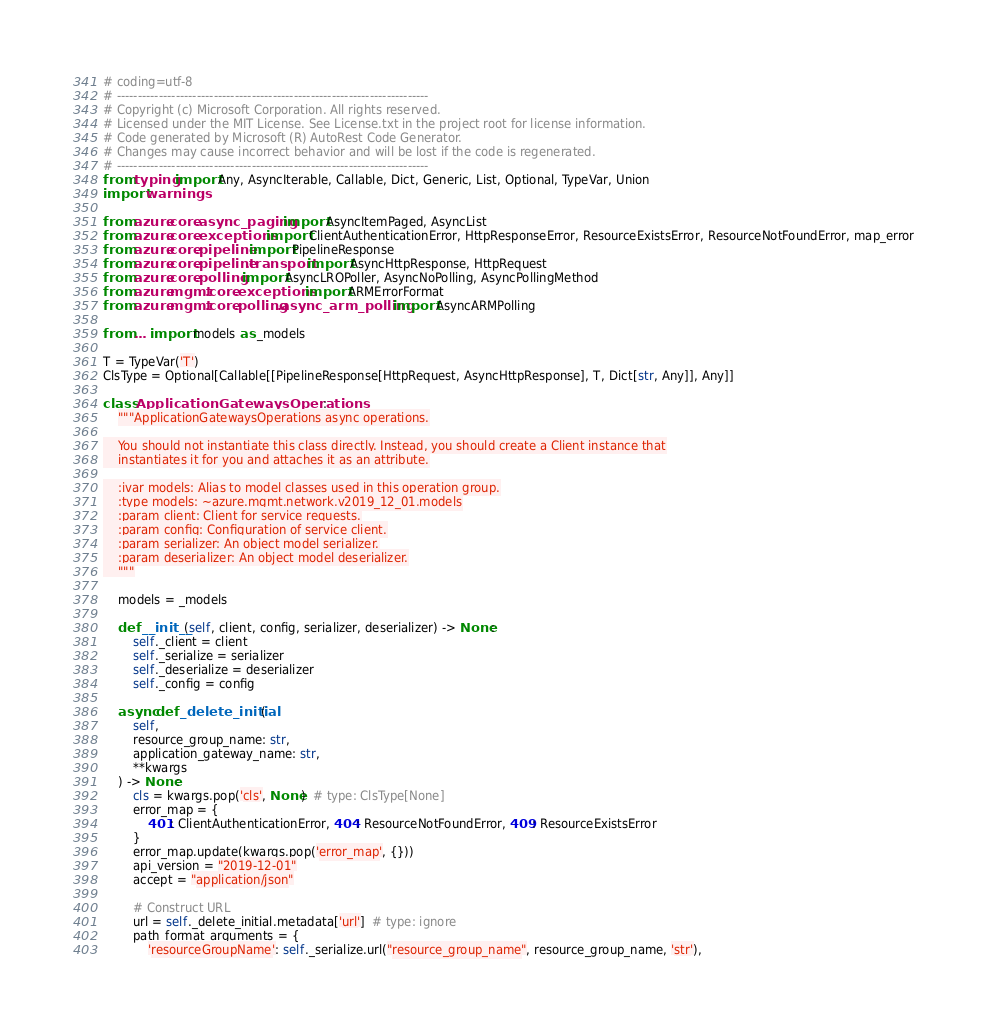<code> <loc_0><loc_0><loc_500><loc_500><_Python_># coding=utf-8
# --------------------------------------------------------------------------
# Copyright (c) Microsoft Corporation. All rights reserved.
# Licensed under the MIT License. See License.txt in the project root for license information.
# Code generated by Microsoft (R) AutoRest Code Generator.
# Changes may cause incorrect behavior and will be lost if the code is regenerated.
# --------------------------------------------------------------------------
from typing import Any, AsyncIterable, Callable, Dict, Generic, List, Optional, TypeVar, Union
import warnings

from azure.core.async_paging import AsyncItemPaged, AsyncList
from azure.core.exceptions import ClientAuthenticationError, HttpResponseError, ResourceExistsError, ResourceNotFoundError, map_error
from azure.core.pipeline import PipelineResponse
from azure.core.pipeline.transport import AsyncHttpResponse, HttpRequest
from azure.core.polling import AsyncLROPoller, AsyncNoPolling, AsyncPollingMethod
from azure.mgmt.core.exceptions import ARMErrorFormat
from azure.mgmt.core.polling.async_arm_polling import AsyncARMPolling

from ... import models as _models

T = TypeVar('T')
ClsType = Optional[Callable[[PipelineResponse[HttpRequest, AsyncHttpResponse], T, Dict[str, Any]], Any]]

class ApplicationGatewaysOperations:
    """ApplicationGatewaysOperations async operations.

    You should not instantiate this class directly. Instead, you should create a Client instance that
    instantiates it for you and attaches it as an attribute.

    :ivar models: Alias to model classes used in this operation group.
    :type models: ~azure.mgmt.network.v2019_12_01.models
    :param client: Client for service requests.
    :param config: Configuration of service client.
    :param serializer: An object model serializer.
    :param deserializer: An object model deserializer.
    """

    models = _models

    def __init__(self, client, config, serializer, deserializer) -> None:
        self._client = client
        self._serialize = serializer
        self._deserialize = deserializer
        self._config = config

    async def _delete_initial(
        self,
        resource_group_name: str,
        application_gateway_name: str,
        **kwargs
    ) -> None:
        cls = kwargs.pop('cls', None)  # type: ClsType[None]
        error_map = {
            401: ClientAuthenticationError, 404: ResourceNotFoundError, 409: ResourceExistsError
        }
        error_map.update(kwargs.pop('error_map', {}))
        api_version = "2019-12-01"
        accept = "application/json"

        # Construct URL
        url = self._delete_initial.metadata['url']  # type: ignore
        path_format_arguments = {
            'resourceGroupName': self._serialize.url("resource_group_name", resource_group_name, 'str'),</code> 